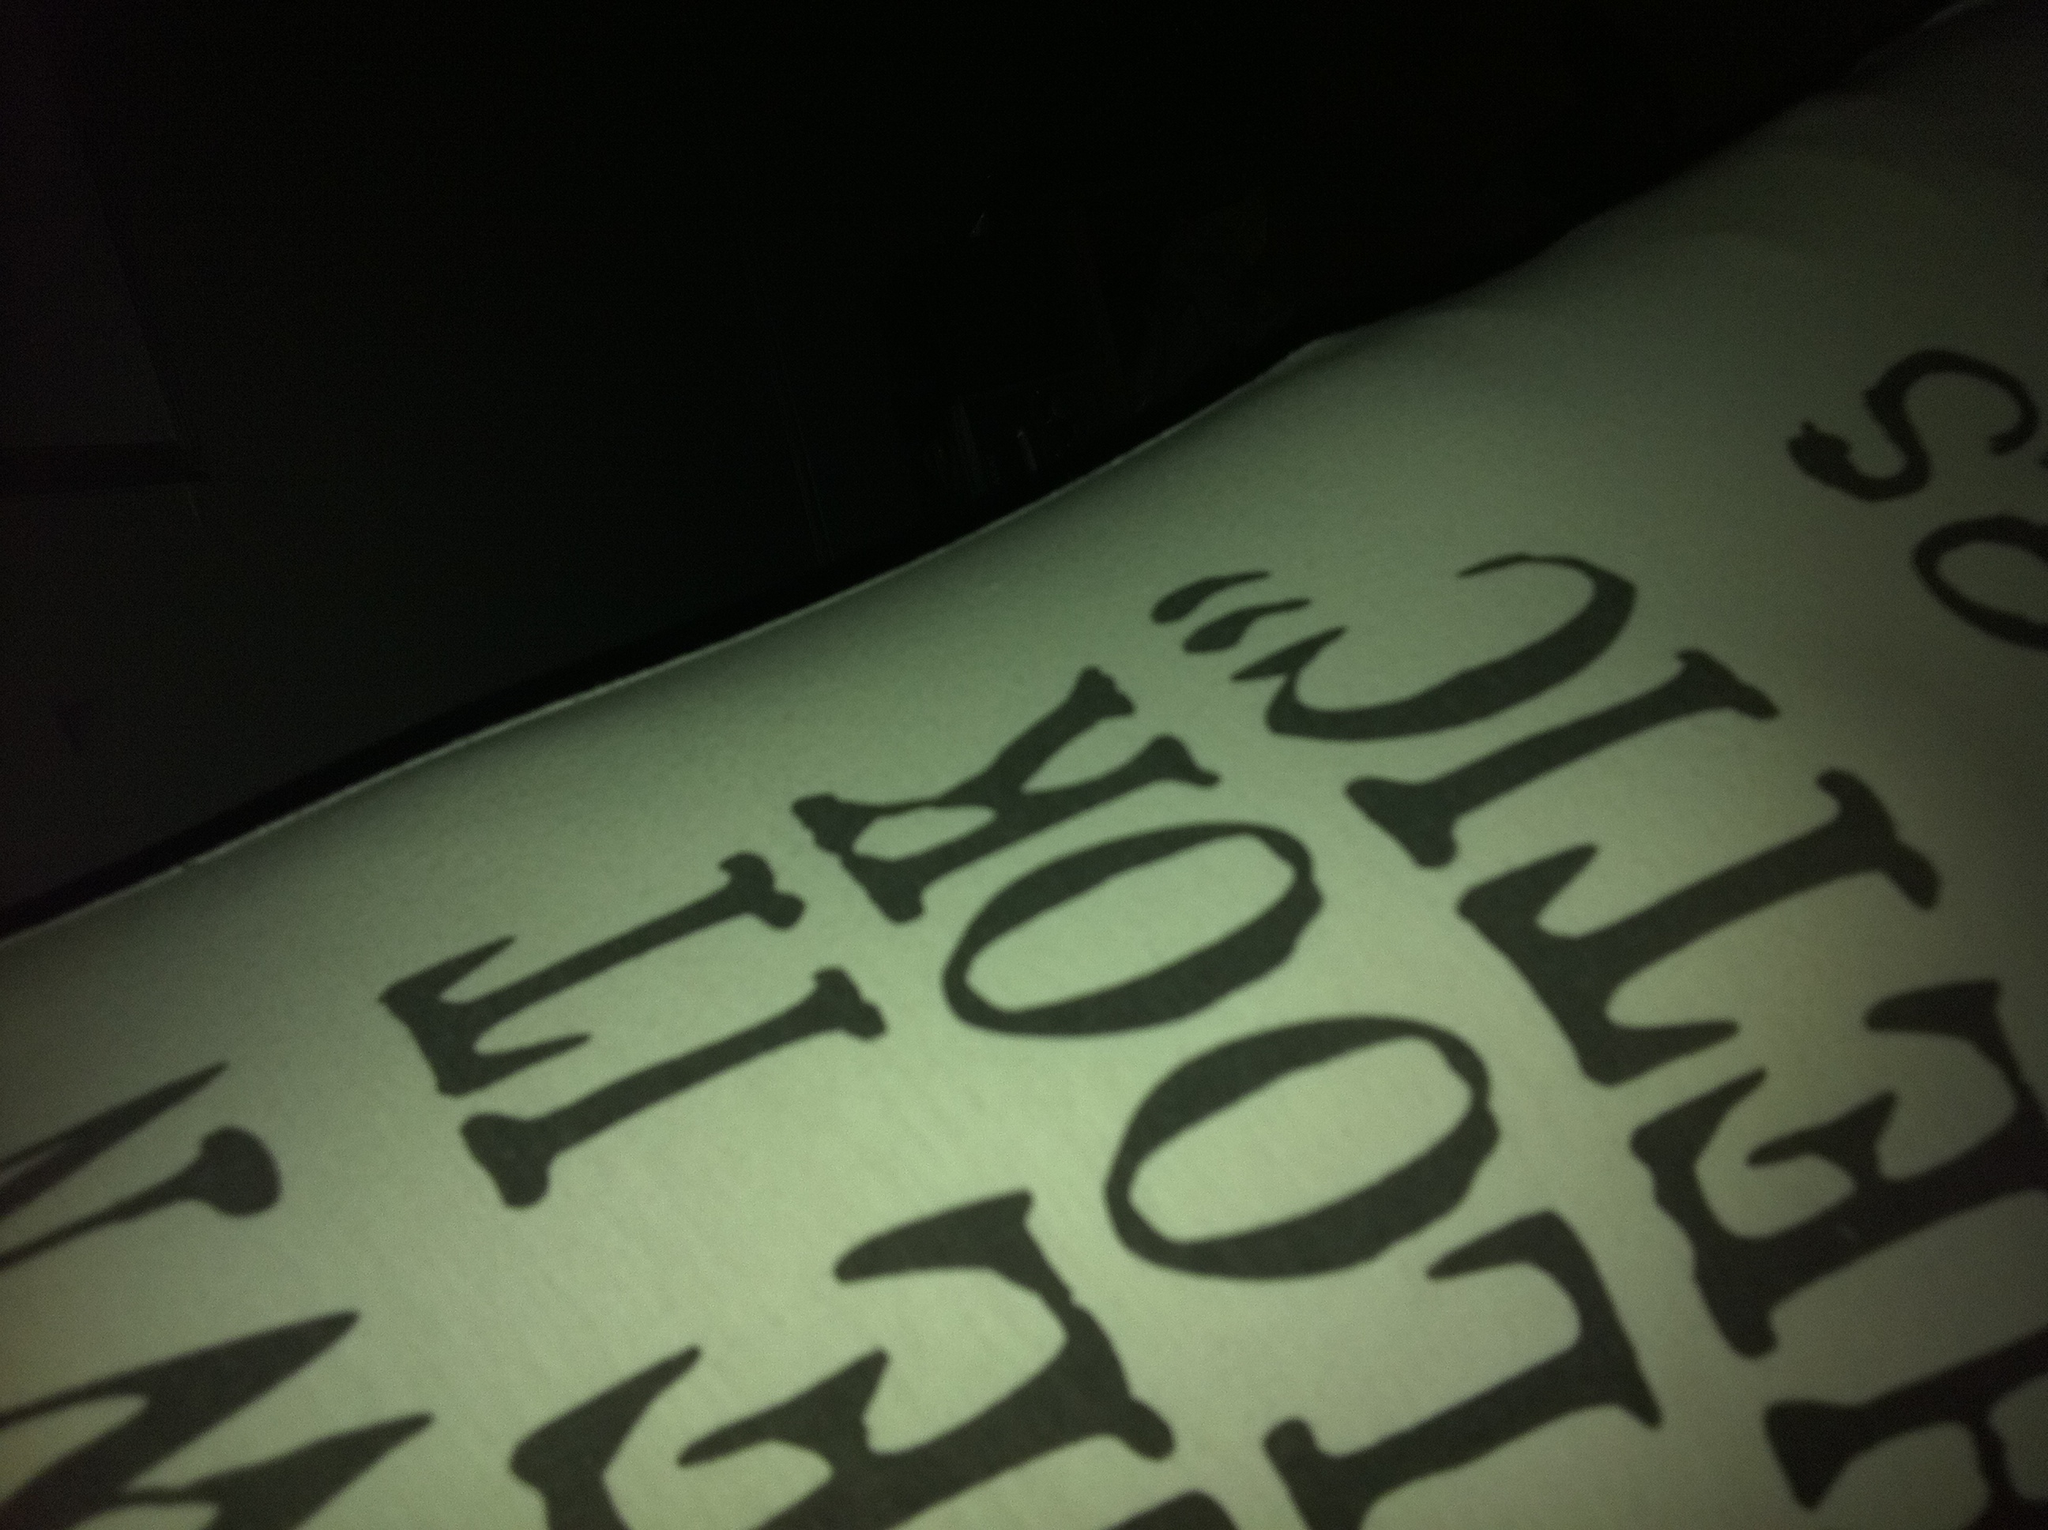Imagine what this text might be part of in a mysterious or adventurous context. In a mysterious or adventurous context, this text could be part of an ancient scroll discovered in a hidden temple. The partial message might be a cryptic clue that adventurers need to decipher to unlock a secret compartment containing a valuable artifact or treasure. The phrase might be something like 'LOOK BEHIND THE' followed by a more intricate puzzle that leads to the next step of their quest. How might this image fit into a romantic setting? In a romantic setting, this image could be part of a surprise note left by a loved one. The black text on the white background might be a portion of a heartfelt message or a clue in a love-themed scavenger hunt. The phrase might be something like 'LOOK UNDER THE PILLOW' where a sweet gift or another affectionate message is hidden. 